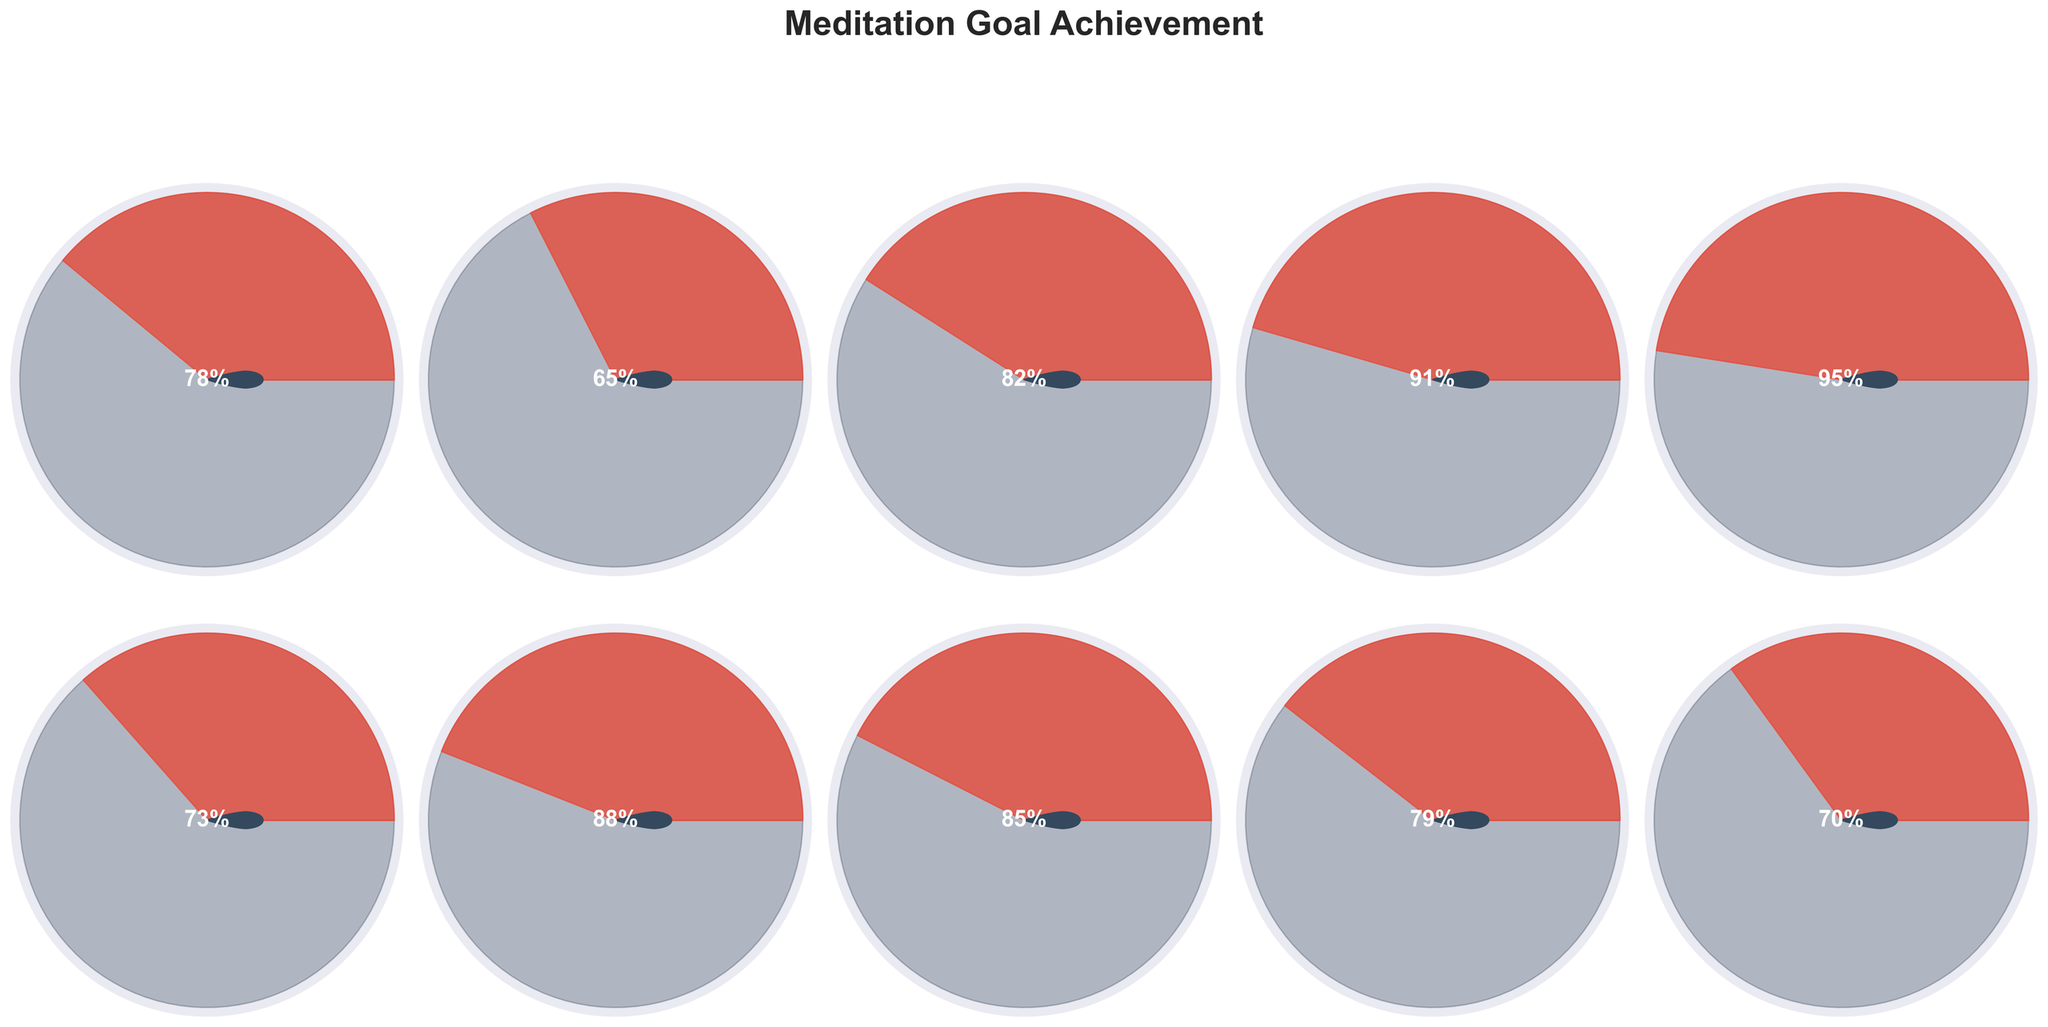Which meditation goal has the highest achievement percentage? By visually inspecting all the gauge charts, the Monthly Retreat Meditation gauge shows the highest percentage achieved which is 95%.
Answer: Monthly Retreat Meditation What is the achievement percentage for Breath Awareness? By locating the specific gauge chart labeled "Breath Awareness," we see that it indicates a 70% achievement.
Answer: 70% How many meditation goals have an achievement less than 80%? By counting the number of gauge charts showing percentages less than 80%, we find that there are four: Midday Reflection, Mindful Walking Practice, Breath Awareness, and Daily Morning Meditation.
Answer: 4 Which meditation goal has an achievement percentage closest to 80%? By comparing the percentages shown in each gauge chart, we see Daily Morning Meditation is at 78% and Mantra Recitation is at 79%, which are both close to 80%. However, Mantra Recitation is mathematically closer.
Answer: Mantra Recitation What is the average achievement percentage of all meditation goals? Add up all the percentages (78 + 65 + 82 + 91 + 95 + 73 + 88 + 85 + 79 + 70) to get 806 and then divide by the number of goals (10) to get the average.
Answer: 80.6% Which meditation goals have achieved more than the average percentage? After calculating the average (80.6%), the goals above this are: Evening Contemplation (82%), Weekly Group Meditation (91%), Monthly Retreat Meditation (95%), Compassion Meditation (88%), and Gratitude Meditation (85%).
Answer: Evening Contemplation, Weekly Group Meditation, Monthly Retreat Meditation, Compassion Meditation, Gratitude Meditation Among Evening Contemplation and Compassion Meditation, which has a higher achievement percentage? By visually comparing the two gauge charts, Evening Contemplation shows an 82% achievement and Compassion Meditation shows an 88% achievement. Compassion Meditation is higher.
Answer: Compassion Meditation What is the combined percentage achievement for the Daily Morning Meditation and the Midday Reflection? Sum the percentages from the Daily Morning Meditation (78%) and the Midday Reflection (65%), which equals 143%.
Answer: 143% Which meditation goals have an achievement percentage between 70% and 90%? By scanning the gauge charts, the goals falling into this range are: Daily Morning Meditation (78%), Midday Reflection (65%), Evening Contemplation (82%), Mindful Walking Practice (73%), Compassion Meditation (88%), Gratitude Meditation (85%), Mantra Recitation (79%), and Breath Awareness (70%).
Answer: Daily Morning Meditation, Midday Reflection, Evening Contemplation, Mindful Walking Practice, Compassion Meditation, Gratitude Meditation, Mantra Recitation, Breath Awareness 